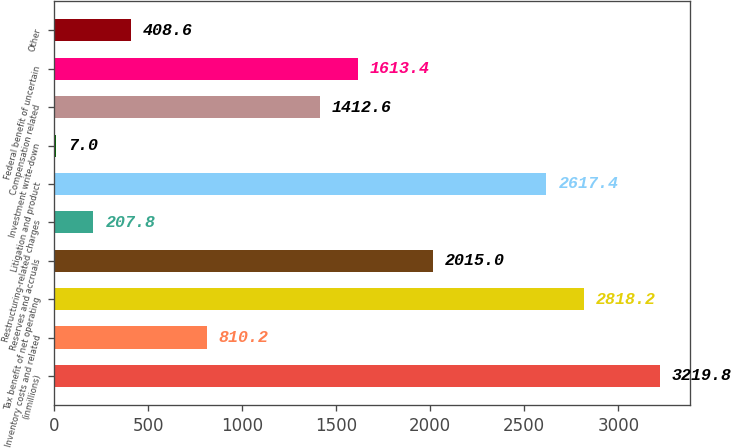<chart> <loc_0><loc_0><loc_500><loc_500><bar_chart><fcel>(inmillions)<fcel>Inventory costs and related<fcel>Tax benefit of net operating<fcel>Reserves and accruals<fcel>Restructuring-related charges<fcel>Litigation and product<fcel>Investment write-down<fcel>Compensation related<fcel>Federal benefit of uncertain<fcel>Other<nl><fcel>3219.8<fcel>810.2<fcel>2818.2<fcel>2015<fcel>207.8<fcel>2617.4<fcel>7<fcel>1412.6<fcel>1613.4<fcel>408.6<nl></chart> 